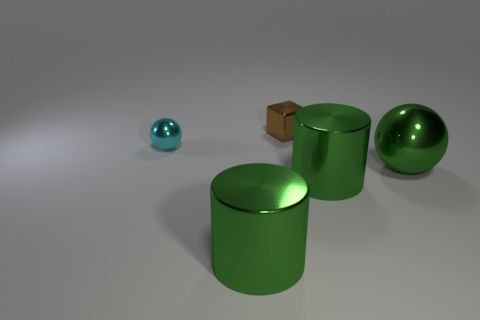Subtract all cyan spheres. How many spheres are left? 1 Add 2 spheres. How many objects exist? 7 Add 2 small cyan metallic balls. How many small cyan metallic balls exist? 3 Subtract 0 purple balls. How many objects are left? 5 Subtract all spheres. How many objects are left? 3 Subtract 1 cylinders. How many cylinders are left? 1 Subtract all cyan cylinders. Subtract all cyan balls. How many cylinders are left? 2 Subtract all green balls. How many purple cylinders are left? 0 Subtract all blue metal cylinders. Subtract all large green cylinders. How many objects are left? 3 Add 5 large green metallic spheres. How many large green metallic spheres are left? 6 